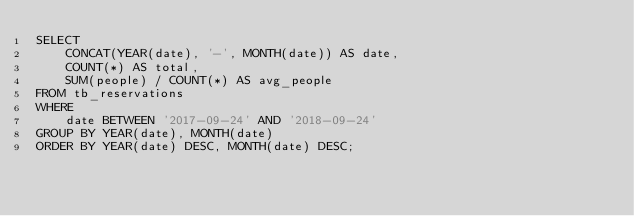<code> <loc_0><loc_0><loc_500><loc_500><_SQL_>SELECT
	CONCAT(YEAR(date), '-', MONTH(date)) AS date,
    COUNT(*) AS total,
    SUM(people) / COUNT(*) AS avg_people
FROM tb_reservations
WHERE
	date BETWEEN '2017-09-24' AND '2018-09-24'
GROUP BY YEAR(date), MONTH(date)
ORDER BY YEAR(date) DESC, MONTH(date) DESC;</code> 